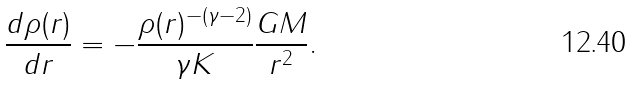<formula> <loc_0><loc_0><loc_500><loc_500>\frac { d \rho ( r ) } { d r } = - \frac { \rho ( r ) ^ { - ( \gamma - 2 ) } } { \gamma K } \frac { G M } { r ^ { 2 } } .</formula> 